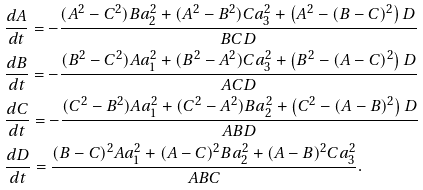Convert formula to latex. <formula><loc_0><loc_0><loc_500><loc_500>& \frac { d A } { d t } = - \frac { ( A ^ { 2 } - C ^ { 2 } ) B a _ { 2 } ^ { 2 } + ( A ^ { 2 } - B ^ { 2 } ) C a _ { 3 } ^ { 2 } + \left ( A ^ { 2 } - ( B - C ) ^ { 2 } \right ) D } { B C D } \\ & \frac { d B } { d t } = - \frac { ( B ^ { 2 } - C ^ { 2 } ) A a _ { 1 } ^ { 2 } + ( B ^ { 2 } - A ^ { 2 } ) C a _ { 3 } ^ { 2 } + \left ( B ^ { 2 } - ( A - C ) ^ { 2 } \right ) D } { A C D } \\ & \frac { d C } { d t } = - \frac { ( C ^ { 2 } - B ^ { 2 } ) A a _ { 1 } ^ { 2 } + ( C ^ { 2 } - A ^ { 2 } ) B a _ { 2 } ^ { 2 } + \left ( C ^ { 2 } - ( A - B ) ^ { 2 } \right ) D } { A B D } \\ & \frac { d D } { d t } = \frac { ( B - C ) ^ { 2 } A a _ { 1 } ^ { 2 } + ( A - C ) ^ { 2 } B a _ { 2 } ^ { 2 } + ( A - B ) ^ { 2 } C a _ { 3 } ^ { 2 } } { A B C } .</formula> 